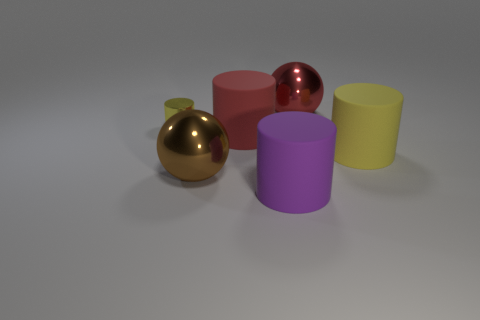Subtract all yellow cylinders. How many were subtracted if there are1yellow cylinders left? 1 Subtract all red matte cylinders. How many cylinders are left? 3 Subtract all red cylinders. How many cylinders are left? 3 Subtract 4 cylinders. How many cylinders are left? 0 Subtract all red spheres. How many red cylinders are left? 1 Add 2 small yellow metal cylinders. How many small yellow metal cylinders exist? 3 Add 3 big yellow things. How many objects exist? 9 Subtract 0 cyan cylinders. How many objects are left? 6 Subtract all cylinders. How many objects are left? 2 Subtract all red spheres. Subtract all cyan cylinders. How many spheres are left? 1 